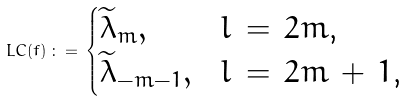Convert formula to latex. <formula><loc_0><loc_0><loc_500><loc_500>L C ( f ) \, \colon = \, \begin{cases} \widetilde { \lambda } _ { m } , & \text {$l \, = \, 2m$,} \\ \widetilde { \lambda } _ { - m - 1 } , & \text {$l \, = \, 2m \, + \, 1$,} \end{cases}</formula> 